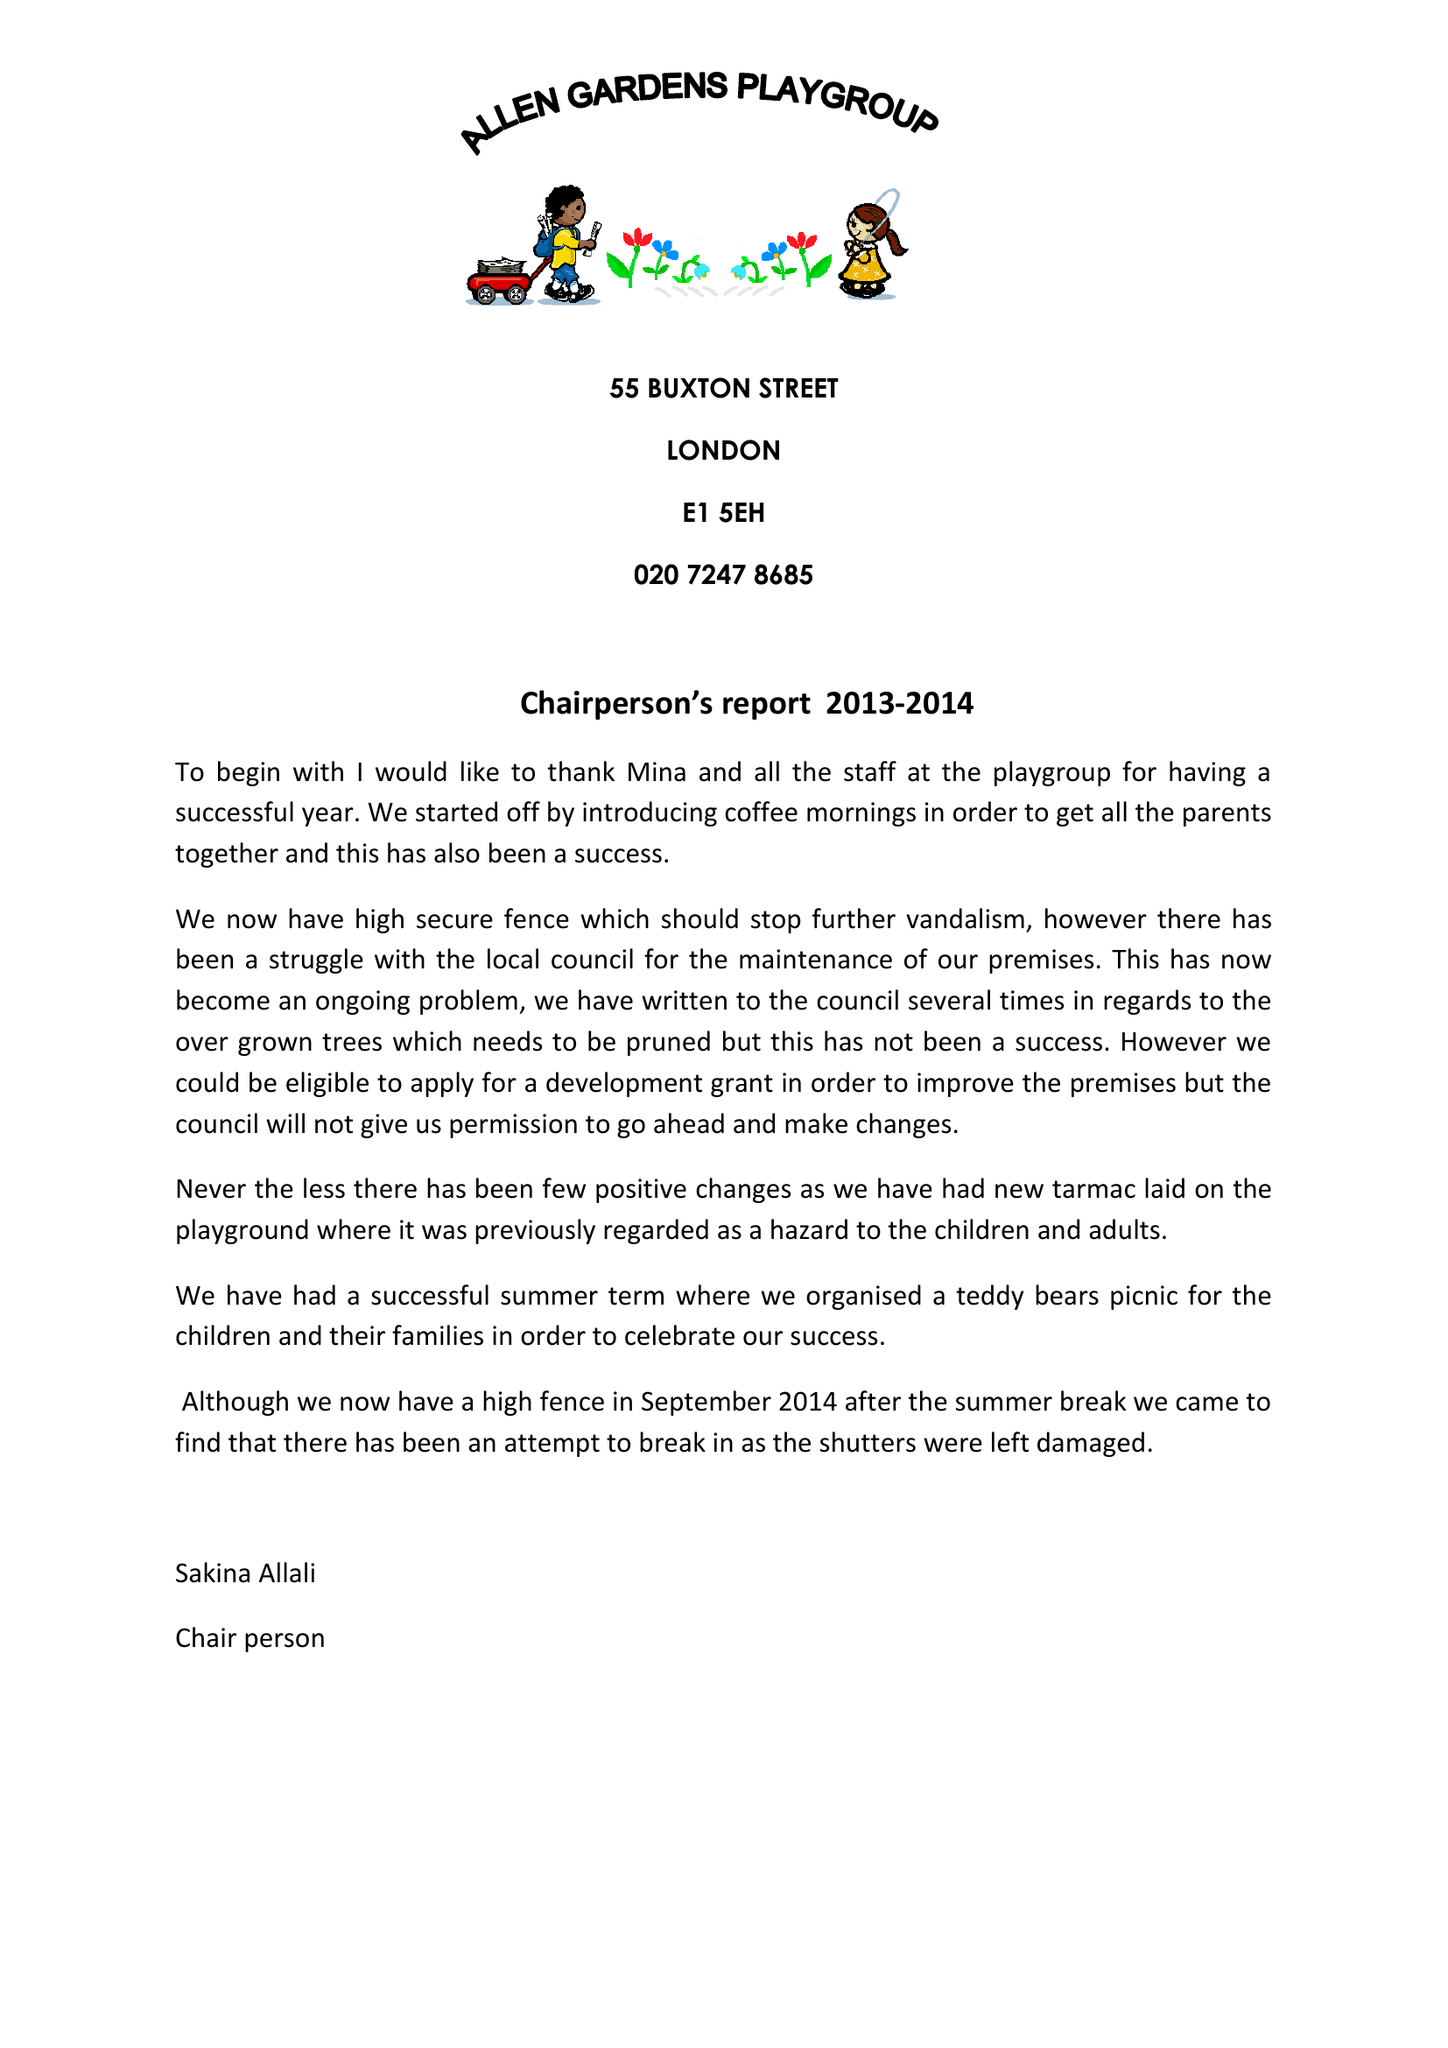What is the value for the report_date?
Answer the question using a single word or phrase. 2014-03-31 